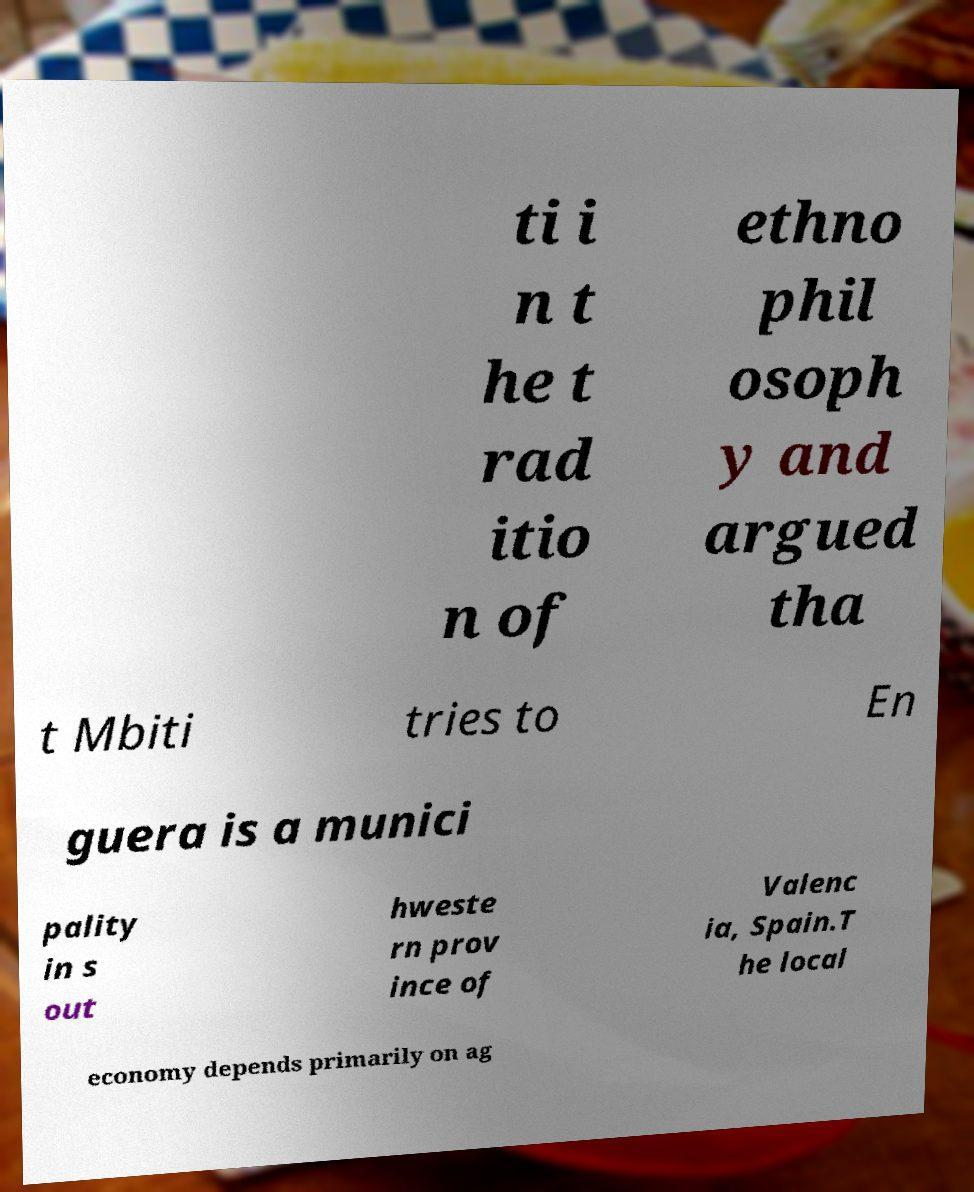Can you read and provide the text displayed in the image?This photo seems to have some interesting text. Can you extract and type it out for me? ti i n t he t rad itio n of ethno phil osoph y and argued tha t Mbiti tries to En guera is a munici pality in s out hweste rn prov ince of Valenc ia, Spain.T he local economy depends primarily on ag 